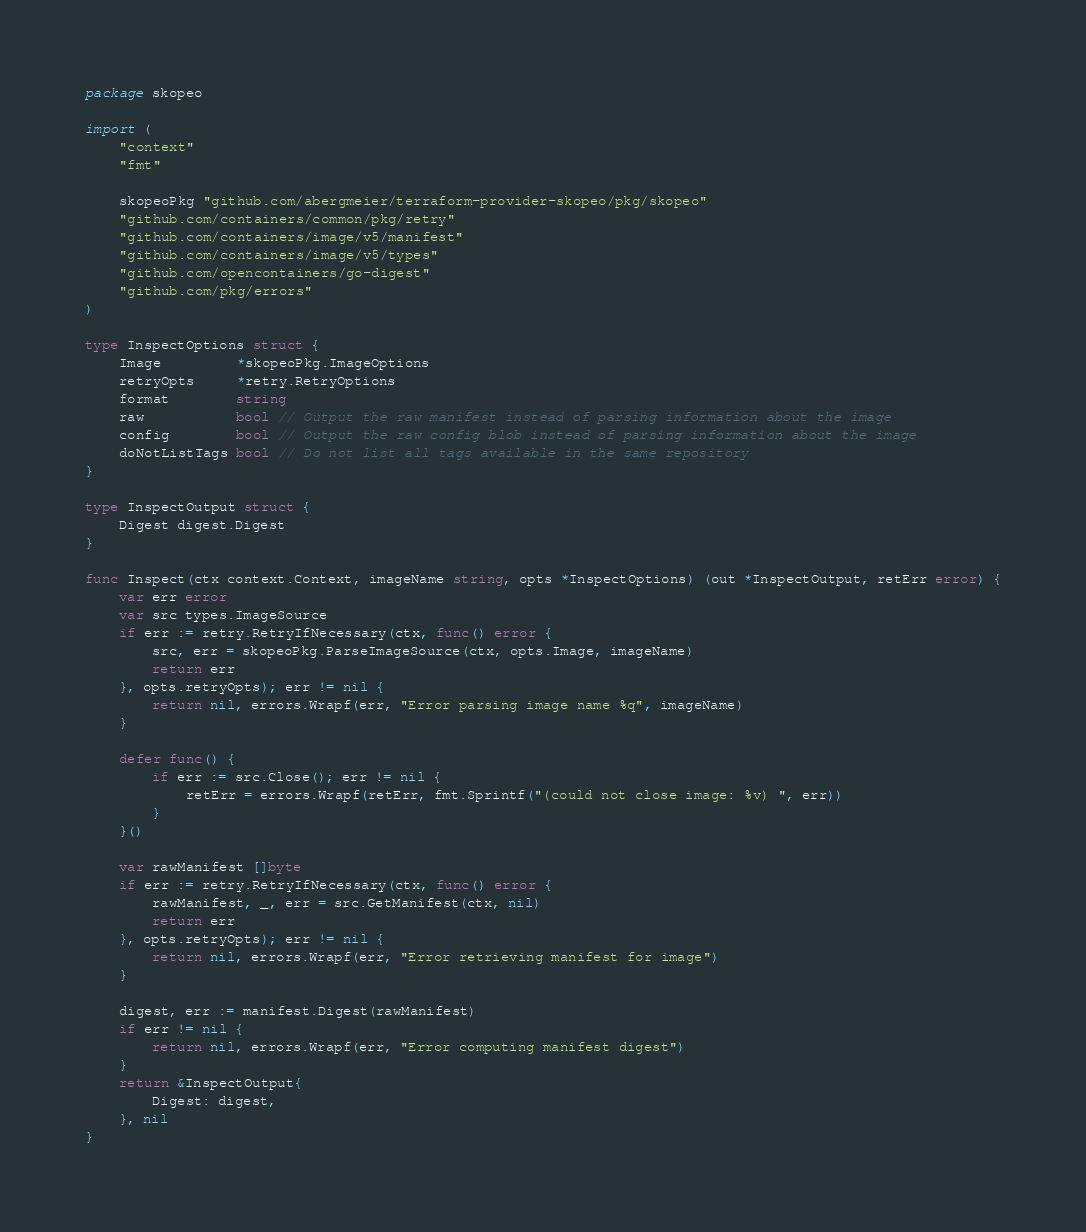<code> <loc_0><loc_0><loc_500><loc_500><_Go_>package skopeo

import (
	"context"
	"fmt"

	skopeoPkg "github.com/abergmeier/terraform-provider-skopeo/pkg/skopeo"
	"github.com/containers/common/pkg/retry"
	"github.com/containers/image/v5/manifest"
	"github.com/containers/image/v5/types"
	"github.com/opencontainers/go-digest"
	"github.com/pkg/errors"
)

type InspectOptions struct {
	Image         *skopeoPkg.ImageOptions
	retryOpts     *retry.RetryOptions
	format        string
	raw           bool // Output the raw manifest instead of parsing information about the image
	config        bool // Output the raw config blob instead of parsing information about the image
	doNotListTags bool // Do not list all tags available in the same repository
}

type InspectOutput struct {
	Digest digest.Digest
}

func Inspect(ctx context.Context, imageName string, opts *InspectOptions) (out *InspectOutput, retErr error) {
	var err error
	var src types.ImageSource
	if err := retry.RetryIfNecessary(ctx, func() error {
		src, err = skopeoPkg.ParseImageSource(ctx, opts.Image, imageName)
		return err
	}, opts.retryOpts); err != nil {
		return nil, errors.Wrapf(err, "Error parsing image name %q", imageName)
	}

	defer func() {
		if err := src.Close(); err != nil {
			retErr = errors.Wrapf(retErr, fmt.Sprintf("(could not close image: %v) ", err))
		}
	}()

	var rawManifest []byte
	if err := retry.RetryIfNecessary(ctx, func() error {
		rawManifest, _, err = src.GetManifest(ctx, nil)
		return err
	}, opts.retryOpts); err != nil {
		return nil, errors.Wrapf(err, "Error retrieving manifest for image")
	}

	digest, err := manifest.Digest(rawManifest)
	if err != nil {
		return nil, errors.Wrapf(err, "Error computing manifest digest")
	}
	return &InspectOutput{
		Digest: digest,
	}, nil
}
</code> 